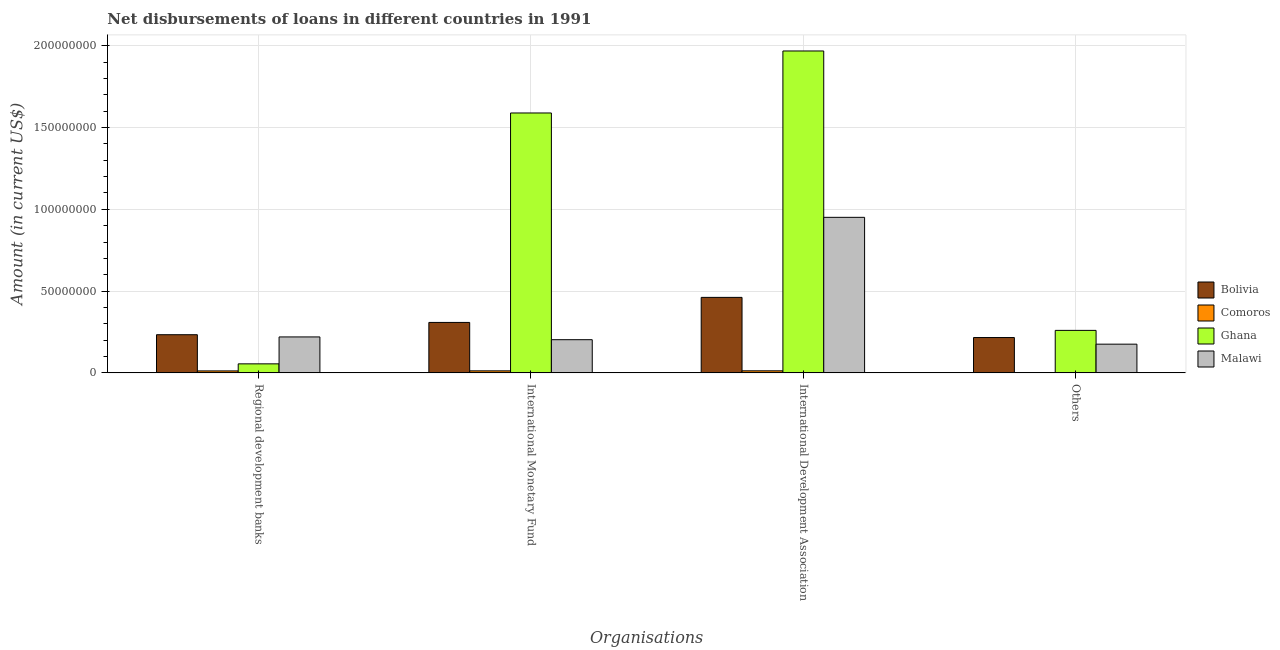How many different coloured bars are there?
Offer a very short reply. 4. Are the number of bars on each tick of the X-axis equal?
Your answer should be compact. No. What is the label of the 2nd group of bars from the left?
Offer a terse response. International Monetary Fund. What is the amount of loan disimbursed by international monetary fund in Ghana?
Provide a short and direct response. 1.59e+08. Across all countries, what is the maximum amount of loan disimbursed by international monetary fund?
Your response must be concise. 1.59e+08. In which country was the amount of loan disimbursed by regional development banks maximum?
Offer a terse response. Bolivia. What is the total amount of loan disimbursed by other organisations in the graph?
Provide a succinct answer. 6.51e+07. What is the difference between the amount of loan disimbursed by international monetary fund in Malawi and that in Comoros?
Give a very brief answer. 1.91e+07. What is the difference between the amount of loan disimbursed by international development association in Ghana and the amount of loan disimbursed by regional development banks in Comoros?
Your response must be concise. 1.96e+08. What is the average amount of loan disimbursed by other organisations per country?
Your response must be concise. 1.63e+07. What is the difference between the amount of loan disimbursed by international monetary fund and amount of loan disimbursed by regional development banks in Ghana?
Your answer should be very brief. 1.53e+08. In how many countries, is the amount of loan disimbursed by other organisations greater than 140000000 US$?
Offer a terse response. 0. What is the ratio of the amount of loan disimbursed by international development association in Malawi to that in Bolivia?
Your response must be concise. 2.06. Is the amount of loan disimbursed by other organisations in Malawi less than that in Bolivia?
Provide a succinct answer. Yes. What is the difference between the highest and the second highest amount of loan disimbursed by other organisations?
Ensure brevity in your answer.  4.38e+06. What is the difference between the highest and the lowest amount of loan disimbursed by regional development banks?
Make the answer very short. 2.21e+07. Is it the case that in every country, the sum of the amount of loan disimbursed by regional development banks and amount of loan disimbursed by other organisations is greater than the sum of amount of loan disimbursed by international monetary fund and amount of loan disimbursed by international development association?
Offer a very short reply. No. Is it the case that in every country, the sum of the amount of loan disimbursed by regional development banks and amount of loan disimbursed by international monetary fund is greater than the amount of loan disimbursed by international development association?
Your response must be concise. No. How many bars are there?
Your response must be concise. 15. How many countries are there in the graph?
Your answer should be very brief. 4. Are the values on the major ticks of Y-axis written in scientific E-notation?
Your response must be concise. No. Where does the legend appear in the graph?
Make the answer very short. Center right. How many legend labels are there?
Provide a succinct answer. 4. How are the legend labels stacked?
Your answer should be very brief. Vertical. What is the title of the graph?
Offer a very short reply. Net disbursements of loans in different countries in 1991. Does "Serbia" appear as one of the legend labels in the graph?
Offer a terse response. No. What is the label or title of the X-axis?
Offer a very short reply. Organisations. What is the label or title of the Y-axis?
Your response must be concise. Amount (in current US$). What is the Amount (in current US$) in Bolivia in Regional development banks?
Provide a succinct answer. 2.33e+07. What is the Amount (in current US$) of Comoros in Regional development banks?
Offer a terse response. 1.20e+06. What is the Amount (in current US$) of Ghana in Regional development banks?
Offer a terse response. 5.51e+06. What is the Amount (in current US$) in Malawi in Regional development banks?
Offer a terse response. 2.20e+07. What is the Amount (in current US$) in Bolivia in International Monetary Fund?
Offer a very short reply. 3.08e+07. What is the Amount (in current US$) of Comoros in International Monetary Fund?
Keep it short and to the point. 1.23e+06. What is the Amount (in current US$) in Ghana in International Monetary Fund?
Your answer should be very brief. 1.59e+08. What is the Amount (in current US$) of Malawi in International Monetary Fund?
Provide a short and direct response. 2.03e+07. What is the Amount (in current US$) in Bolivia in International Development Association?
Provide a short and direct response. 4.62e+07. What is the Amount (in current US$) of Comoros in International Development Association?
Offer a terse response. 1.25e+06. What is the Amount (in current US$) in Ghana in International Development Association?
Your answer should be very brief. 1.97e+08. What is the Amount (in current US$) of Malawi in International Development Association?
Keep it short and to the point. 9.51e+07. What is the Amount (in current US$) of Bolivia in Others?
Offer a very short reply. 2.16e+07. What is the Amount (in current US$) of Comoros in Others?
Ensure brevity in your answer.  0. What is the Amount (in current US$) of Ghana in Others?
Ensure brevity in your answer.  2.60e+07. What is the Amount (in current US$) in Malawi in Others?
Keep it short and to the point. 1.75e+07. Across all Organisations, what is the maximum Amount (in current US$) of Bolivia?
Ensure brevity in your answer.  4.62e+07. Across all Organisations, what is the maximum Amount (in current US$) of Comoros?
Your answer should be compact. 1.25e+06. Across all Organisations, what is the maximum Amount (in current US$) of Ghana?
Provide a succinct answer. 1.97e+08. Across all Organisations, what is the maximum Amount (in current US$) in Malawi?
Ensure brevity in your answer.  9.51e+07. Across all Organisations, what is the minimum Amount (in current US$) in Bolivia?
Your response must be concise. 2.16e+07. Across all Organisations, what is the minimum Amount (in current US$) of Ghana?
Give a very brief answer. 5.51e+06. Across all Organisations, what is the minimum Amount (in current US$) in Malawi?
Provide a succinct answer. 1.75e+07. What is the total Amount (in current US$) of Bolivia in the graph?
Provide a short and direct response. 1.22e+08. What is the total Amount (in current US$) in Comoros in the graph?
Your response must be concise. 3.68e+06. What is the total Amount (in current US$) in Ghana in the graph?
Ensure brevity in your answer.  3.87e+08. What is the total Amount (in current US$) in Malawi in the graph?
Give a very brief answer. 1.55e+08. What is the difference between the Amount (in current US$) of Bolivia in Regional development banks and that in International Monetary Fund?
Give a very brief answer. -7.50e+06. What is the difference between the Amount (in current US$) of Comoros in Regional development banks and that in International Monetary Fund?
Provide a short and direct response. -3.60e+04. What is the difference between the Amount (in current US$) in Ghana in Regional development banks and that in International Monetary Fund?
Keep it short and to the point. -1.53e+08. What is the difference between the Amount (in current US$) in Malawi in Regional development banks and that in International Monetary Fund?
Keep it short and to the point. 1.69e+06. What is the difference between the Amount (in current US$) in Bolivia in Regional development banks and that in International Development Association?
Your response must be concise. -2.28e+07. What is the difference between the Amount (in current US$) in Comoros in Regional development banks and that in International Development Association?
Make the answer very short. -5.70e+04. What is the difference between the Amount (in current US$) in Ghana in Regional development banks and that in International Development Association?
Provide a short and direct response. -1.91e+08. What is the difference between the Amount (in current US$) in Malawi in Regional development banks and that in International Development Association?
Offer a very short reply. -7.31e+07. What is the difference between the Amount (in current US$) of Bolivia in Regional development banks and that in Others?
Your answer should be very brief. 1.74e+06. What is the difference between the Amount (in current US$) in Ghana in Regional development banks and that in Others?
Your answer should be compact. -2.05e+07. What is the difference between the Amount (in current US$) in Malawi in Regional development banks and that in Others?
Your response must be concise. 4.43e+06. What is the difference between the Amount (in current US$) in Bolivia in International Monetary Fund and that in International Development Association?
Offer a terse response. -1.53e+07. What is the difference between the Amount (in current US$) of Comoros in International Monetary Fund and that in International Development Association?
Keep it short and to the point. -2.10e+04. What is the difference between the Amount (in current US$) in Ghana in International Monetary Fund and that in International Development Association?
Make the answer very short. -3.79e+07. What is the difference between the Amount (in current US$) of Malawi in International Monetary Fund and that in International Development Association?
Offer a very short reply. -7.48e+07. What is the difference between the Amount (in current US$) in Bolivia in International Monetary Fund and that in Others?
Your response must be concise. 9.24e+06. What is the difference between the Amount (in current US$) of Ghana in International Monetary Fund and that in Others?
Give a very brief answer. 1.33e+08. What is the difference between the Amount (in current US$) of Malawi in International Monetary Fund and that in Others?
Offer a terse response. 2.74e+06. What is the difference between the Amount (in current US$) of Bolivia in International Development Association and that in Others?
Your answer should be compact. 2.46e+07. What is the difference between the Amount (in current US$) in Ghana in International Development Association and that in Others?
Make the answer very short. 1.71e+08. What is the difference between the Amount (in current US$) of Malawi in International Development Association and that in Others?
Make the answer very short. 7.76e+07. What is the difference between the Amount (in current US$) of Bolivia in Regional development banks and the Amount (in current US$) of Comoros in International Monetary Fund?
Your answer should be very brief. 2.21e+07. What is the difference between the Amount (in current US$) of Bolivia in Regional development banks and the Amount (in current US$) of Ghana in International Monetary Fund?
Ensure brevity in your answer.  -1.36e+08. What is the difference between the Amount (in current US$) in Bolivia in Regional development banks and the Amount (in current US$) in Malawi in International Monetary Fund?
Give a very brief answer. 3.05e+06. What is the difference between the Amount (in current US$) in Comoros in Regional development banks and the Amount (in current US$) in Ghana in International Monetary Fund?
Keep it short and to the point. -1.58e+08. What is the difference between the Amount (in current US$) of Comoros in Regional development banks and the Amount (in current US$) of Malawi in International Monetary Fund?
Keep it short and to the point. -1.91e+07. What is the difference between the Amount (in current US$) in Ghana in Regional development banks and the Amount (in current US$) in Malawi in International Monetary Fund?
Give a very brief answer. -1.48e+07. What is the difference between the Amount (in current US$) of Bolivia in Regional development banks and the Amount (in current US$) of Comoros in International Development Association?
Provide a short and direct response. 2.21e+07. What is the difference between the Amount (in current US$) in Bolivia in Regional development banks and the Amount (in current US$) in Ghana in International Development Association?
Your response must be concise. -1.74e+08. What is the difference between the Amount (in current US$) of Bolivia in Regional development banks and the Amount (in current US$) of Malawi in International Development Association?
Give a very brief answer. -7.18e+07. What is the difference between the Amount (in current US$) of Comoros in Regional development banks and the Amount (in current US$) of Ghana in International Development Association?
Your answer should be very brief. -1.96e+08. What is the difference between the Amount (in current US$) in Comoros in Regional development banks and the Amount (in current US$) in Malawi in International Development Association?
Provide a succinct answer. -9.39e+07. What is the difference between the Amount (in current US$) in Ghana in Regional development banks and the Amount (in current US$) in Malawi in International Development Association?
Keep it short and to the point. -8.96e+07. What is the difference between the Amount (in current US$) in Bolivia in Regional development banks and the Amount (in current US$) in Ghana in Others?
Offer a very short reply. -2.64e+06. What is the difference between the Amount (in current US$) of Bolivia in Regional development banks and the Amount (in current US$) of Malawi in Others?
Ensure brevity in your answer.  5.79e+06. What is the difference between the Amount (in current US$) in Comoros in Regional development banks and the Amount (in current US$) in Ghana in Others?
Keep it short and to the point. -2.48e+07. What is the difference between the Amount (in current US$) in Comoros in Regional development banks and the Amount (in current US$) in Malawi in Others?
Your answer should be compact. -1.64e+07. What is the difference between the Amount (in current US$) of Ghana in Regional development banks and the Amount (in current US$) of Malawi in Others?
Keep it short and to the point. -1.20e+07. What is the difference between the Amount (in current US$) of Bolivia in International Monetary Fund and the Amount (in current US$) of Comoros in International Development Association?
Ensure brevity in your answer.  2.96e+07. What is the difference between the Amount (in current US$) in Bolivia in International Monetary Fund and the Amount (in current US$) in Ghana in International Development Association?
Keep it short and to the point. -1.66e+08. What is the difference between the Amount (in current US$) of Bolivia in International Monetary Fund and the Amount (in current US$) of Malawi in International Development Association?
Your answer should be very brief. -6.43e+07. What is the difference between the Amount (in current US$) in Comoros in International Monetary Fund and the Amount (in current US$) in Ghana in International Development Association?
Offer a very short reply. -1.96e+08. What is the difference between the Amount (in current US$) of Comoros in International Monetary Fund and the Amount (in current US$) of Malawi in International Development Association?
Your response must be concise. -9.39e+07. What is the difference between the Amount (in current US$) in Ghana in International Monetary Fund and the Amount (in current US$) in Malawi in International Development Association?
Offer a terse response. 6.38e+07. What is the difference between the Amount (in current US$) of Bolivia in International Monetary Fund and the Amount (in current US$) of Ghana in Others?
Provide a short and direct response. 4.86e+06. What is the difference between the Amount (in current US$) of Bolivia in International Monetary Fund and the Amount (in current US$) of Malawi in Others?
Ensure brevity in your answer.  1.33e+07. What is the difference between the Amount (in current US$) of Comoros in International Monetary Fund and the Amount (in current US$) of Ghana in Others?
Your answer should be very brief. -2.47e+07. What is the difference between the Amount (in current US$) of Comoros in International Monetary Fund and the Amount (in current US$) of Malawi in Others?
Ensure brevity in your answer.  -1.63e+07. What is the difference between the Amount (in current US$) in Ghana in International Monetary Fund and the Amount (in current US$) in Malawi in Others?
Offer a terse response. 1.41e+08. What is the difference between the Amount (in current US$) of Bolivia in International Development Association and the Amount (in current US$) of Ghana in Others?
Your answer should be very brief. 2.02e+07. What is the difference between the Amount (in current US$) in Bolivia in International Development Association and the Amount (in current US$) in Malawi in Others?
Provide a short and direct response. 2.86e+07. What is the difference between the Amount (in current US$) of Comoros in International Development Association and the Amount (in current US$) of Ghana in Others?
Your answer should be very brief. -2.47e+07. What is the difference between the Amount (in current US$) of Comoros in International Development Association and the Amount (in current US$) of Malawi in Others?
Offer a very short reply. -1.63e+07. What is the difference between the Amount (in current US$) of Ghana in International Development Association and the Amount (in current US$) of Malawi in Others?
Offer a very short reply. 1.79e+08. What is the average Amount (in current US$) of Bolivia per Organisations?
Make the answer very short. 3.05e+07. What is the average Amount (in current US$) in Comoros per Organisations?
Offer a very short reply. 9.20e+05. What is the average Amount (in current US$) in Ghana per Organisations?
Offer a terse response. 9.68e+07. What is the average Amount (in current US$) of Malawi per Organisations?
Your response must be concise. 3.87e+07. What is the difference between the Amount (in current US$) of Bolivia and Amount (in current US$) of Comoros in Regional development banks?
Make the answer very short. 2.21e+07. What is the difference between the Amount (in current US$) in Bolivia and Amount (in current US$) in Ghana in Regional development banks?
Keep it short and to the point. 1.78e+07. What is the difference between the Amount (in current US$) of Bolivia and Amount (in current US$) of Malawi in Regional development banks?
Make the answer very short. 1.36e+06. What is the difference between the Amount (in current US$) of Comoros and Amount (in current US$) of Ghana in Regional development banks?
Ensure brevity in your answer.  -4.32e+06. What is the difference between the Amount (in current US$) in Comoros and Amount (in current US$) in Malawi in Regional development banks?
Provide a succinct answer. -2.08e+07. What is the difference between the Amount (in current US$) of Ghana and Amount (in current US$) of Malawi in Regional development banks?
Keep it short and to the point. -1.65e+07. What is the difference between the Amount (in current US$) in Bolivia and Amount (in current US$) in Comoros in International Monetary Fund?
Make the answer very short. 2.96e+07. What is the difference between the Amount (in current US$) of Bolivia and Amount (in current US$) of Ghana in International Monetary Fund?
Provide a short and direct response. -1.28e+08. What is the difference between the Amount (in current US$) of Bolivia and Amount (in current US$) of Malawi in International Monetary Fund?
Offer a terse response. 1.06e+07. What is the difference between the Amount (in current US$) of Comoros and Amount (in current US$) of Ghana in International Monetary Fund?
Provide a succinct answer. -1.58e+08. What is the difference between the Amount (in current US$) of Comoros and Amount (in current US$) of Malawi in International Monetary Fund?
Your answer should be very brief. -1.91e+07. What is the difference between the Amount (in current US$) in Ghana and Amount (in current US$) in Malawi in International Monetary Fund?
Keep it short and to the point. 1.39e+08. What is the difference between the Amount (in current US$) in Bolivia and Amount (in current US$) in Comoros in International Development Association?
Make the answer very short. 4.49e+07. What is the difference between the Amount (in current US$) in Bolivia and Amount (in current US$) in Ghana in International Development Association?
Give a very brief answer. -1.51e+08. What is the difference between the Amount (in current US$) in Bolivia and Amount (in current US$) in Malawi in International Development Association?
Make the answer very short. -4.89e+07. What is the difference between the Amount (in current US$) of Comoros and Amount (in current US$) of Ghana in International Development Association?
Provide a succinct answer. -1.96e+08. What is the difference between the Amount (in current US$) of Comoros and Amount (in current US$) of Malawi in International Development Association?
Ensure brevity in your answer.  -9.38e+07. What is the difference between the Amount (in current US$) in Ghana and Amount (in current US$) in Malawi in International Development Association?
Provide a succinct answer. 1.02e+08. What is the difference between the Amount (in current US$) in Bolivia and Amount (in current US$) in Ghana in Others?
Keep it short and to the point. -4.38e+06. What is the difference between the Amount (in current US$) of Bolivia and Amount (in current US$) of Malawi in Others?
Make the answer very short. 4.05e+06. What is the difference between the Amount (in current US$) of Ghana and Amount (in current US$) of Malawi in Others?
Provide a short and direct response. 8.43e+06. What is the ratio of the Amount (in current US$) in Bolivia in Regional development banks to that in International Monetary Fund?
Your answer should be compact. 0.76. What is the ratio of the Amount (in current US$) of Comoros in Regional development banks to that in International Monetary Fund?
Ensure brevity in your answer.  0.97. What is the ratio of the Amount (in current US$) of Ghana in Regional development banks to that in International Monetary Fund?
Your answer should be compact. 0.03. What is the ratio of the Amount (in current US$) in Malawi in Regional development banks to that in International Monetary Fund?
Offer a very short reply. 1.08. What is the ratio of the Amount (in current US$) of Bolivia in Regional development banks to that in International Development Association?
Offer a very short reply. 0.51. What is the ratio of the Amount (in current US$) of Comoros in Regional development banks to that in International Development Association?
Ensure brevity in your answer.  0.95. What is the ratio of the Amount (in current US$) in Ghana in Regional development banks to that in International Development Association?
Keep it short and to the point. 0.03. What is the ratio of the Amount (in current US$) of Malawi in Regional development banks to that in International Development Association?
Your answer should be compact. 0.23. What is the ratio of the Amount (in current US$) of Bolivia in Regional development banks to that in Others?
Your answer should be compact. 1.08. What is the ratio of the Amount (in current US$) in Ghana in Regional development banks to that in Others?
Offer a very short reply. 0.21. What is the ratio of the Amount (in current US$) in Malawi in Regional development banks to that in Others?
Offer a terse response. 1.25. What is the ratio of the Amount (in current US$) in Bolivia in International Monetary Fund to that in International Development Association?
Your response must be concise. 0.67. What is the ratio of the Amount (in current US$) in Comoros in International Monetary Fund to that in International Development Association?
Offer a terse response. 0.98. What is the ratio of the Amount (in current US$) in Ghana in International Monetary Fund to that in International Development Association?
Ensure brevity in your answer.  0.81. What is the ratio of the Amount (in current US$) in Malawi in International Monetary Fund to that in International Development Association?
Offer a terse response. 0.21. What is the ratio of the Amount (in current US$) in Bolivia in International Monetary Fund to that in Others?
Provide a succinct answer. 1.43. What is the ratio of the Amount (in current US$) in Ghana in International Monetary Fund to that in Others?
Offer a terse response. 6.12. What is the ratio of the Amount (in current US$) in Malawi in International Monetary Fund to that in Others?
Offer a very short reply. 1.16. What is the ratio of the Amount (in current US$) of Bolivia in International Development Association to that in Others?
Give a very brief answer. 2.14. What is the ratio of the Amount (in current US$) in Ghana in International Development Association to that in Others?
Make the answer very short. 7.58. What is the ratio of the Amount (in current US$) in Malawi in International Development Association to that in Others?
Your answer should be very brief. 5.42. What is the difference between the highest and the second highest Amount (in current US$) of Bolivia?
Give a very brief answer. 1.53e+07. What is the difference between the highest and the second highest Amount (in current US$) of Comoros?
Keep it short and to the point. 2.10e+04. What is the difference between the highest and the second highest Amount (in current US$) of Ghana?
Ensure brevity in your answer.  3.79e+07. What is the difference between the highest and the second highest Amount (in current US$) in Malawi?
Give a very brief answer. 7.31e+07. What is the difference between the highest and the lowest Amount (in current US$) in Bolivia?
Ensure brevity in your answer.  2.46e+07. What is the difference between the highest and the lowest Amount (in current US$) in Comoros?
Keep it short and to the point. 1.25e+06. What is the difference between the highest and the lowest Amount (in current US$) in Ghana?
Keep it short and to the point. 1.91e+08. What is the difference between the highest and the lowest Amount (in current US$) in Malawi?
Your answer should be very brief. 7.76e+07. 